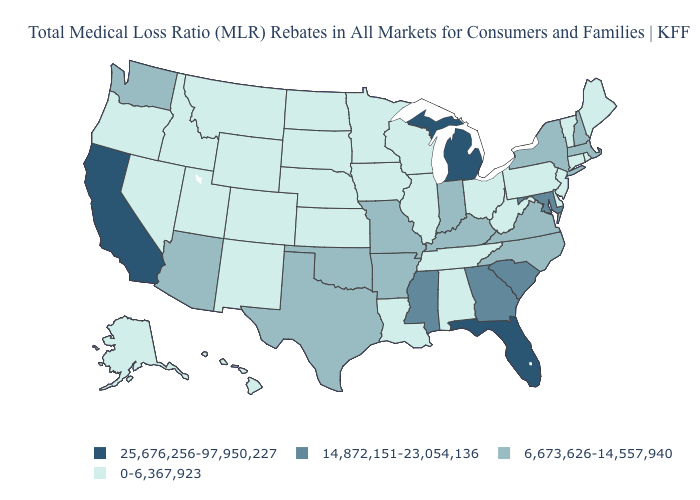Which states hav the highest value in the Northeast?
Be succinct. Massachusetts, New Hampshire, New York. Is the legend a continuous bar?
Answer briefly. No. Name the states that have a value in the range 6,673,626-14,557,940?
Give a very brief answer. Arizona, Arkansas, Indiana, Kentucky, Massachusetts, Missouri, New Hampshire, New York, North Carolina, Oklahoma, Texas, Virginia, Washington. Does Montana have a lower value than Vermont?
Give a very brief answer. No. How many symbols are there in the legend?
Short answer required. 4. What is the value of North Dakota?
Keep it brief. 0-6,367,923. Does Iowa have a higher value than Massachusetts?
Be succinct. No. What is the lowest value in the South?
Quick response, please. 0-6,367,923. Does Virginia have a lower value than California?
Keep it brief. Yes. Does California have the highest value in the USA?
Give a very brief answer. Yes. Is the legend a continuous bar?
Write a very short answer. No. What is the value of Mississippi?
Quick response, please. 14,872,151-23,054,136. What is the value of Kentucky?
Concise answer only. 6,673,626-14,557,940. Does Arizona have a higher value than West Virginia?
Be succinct. Yes. Among the states that border Kansas , which have the highest value?
Concise answer only. Missouri, Oklahoma. 